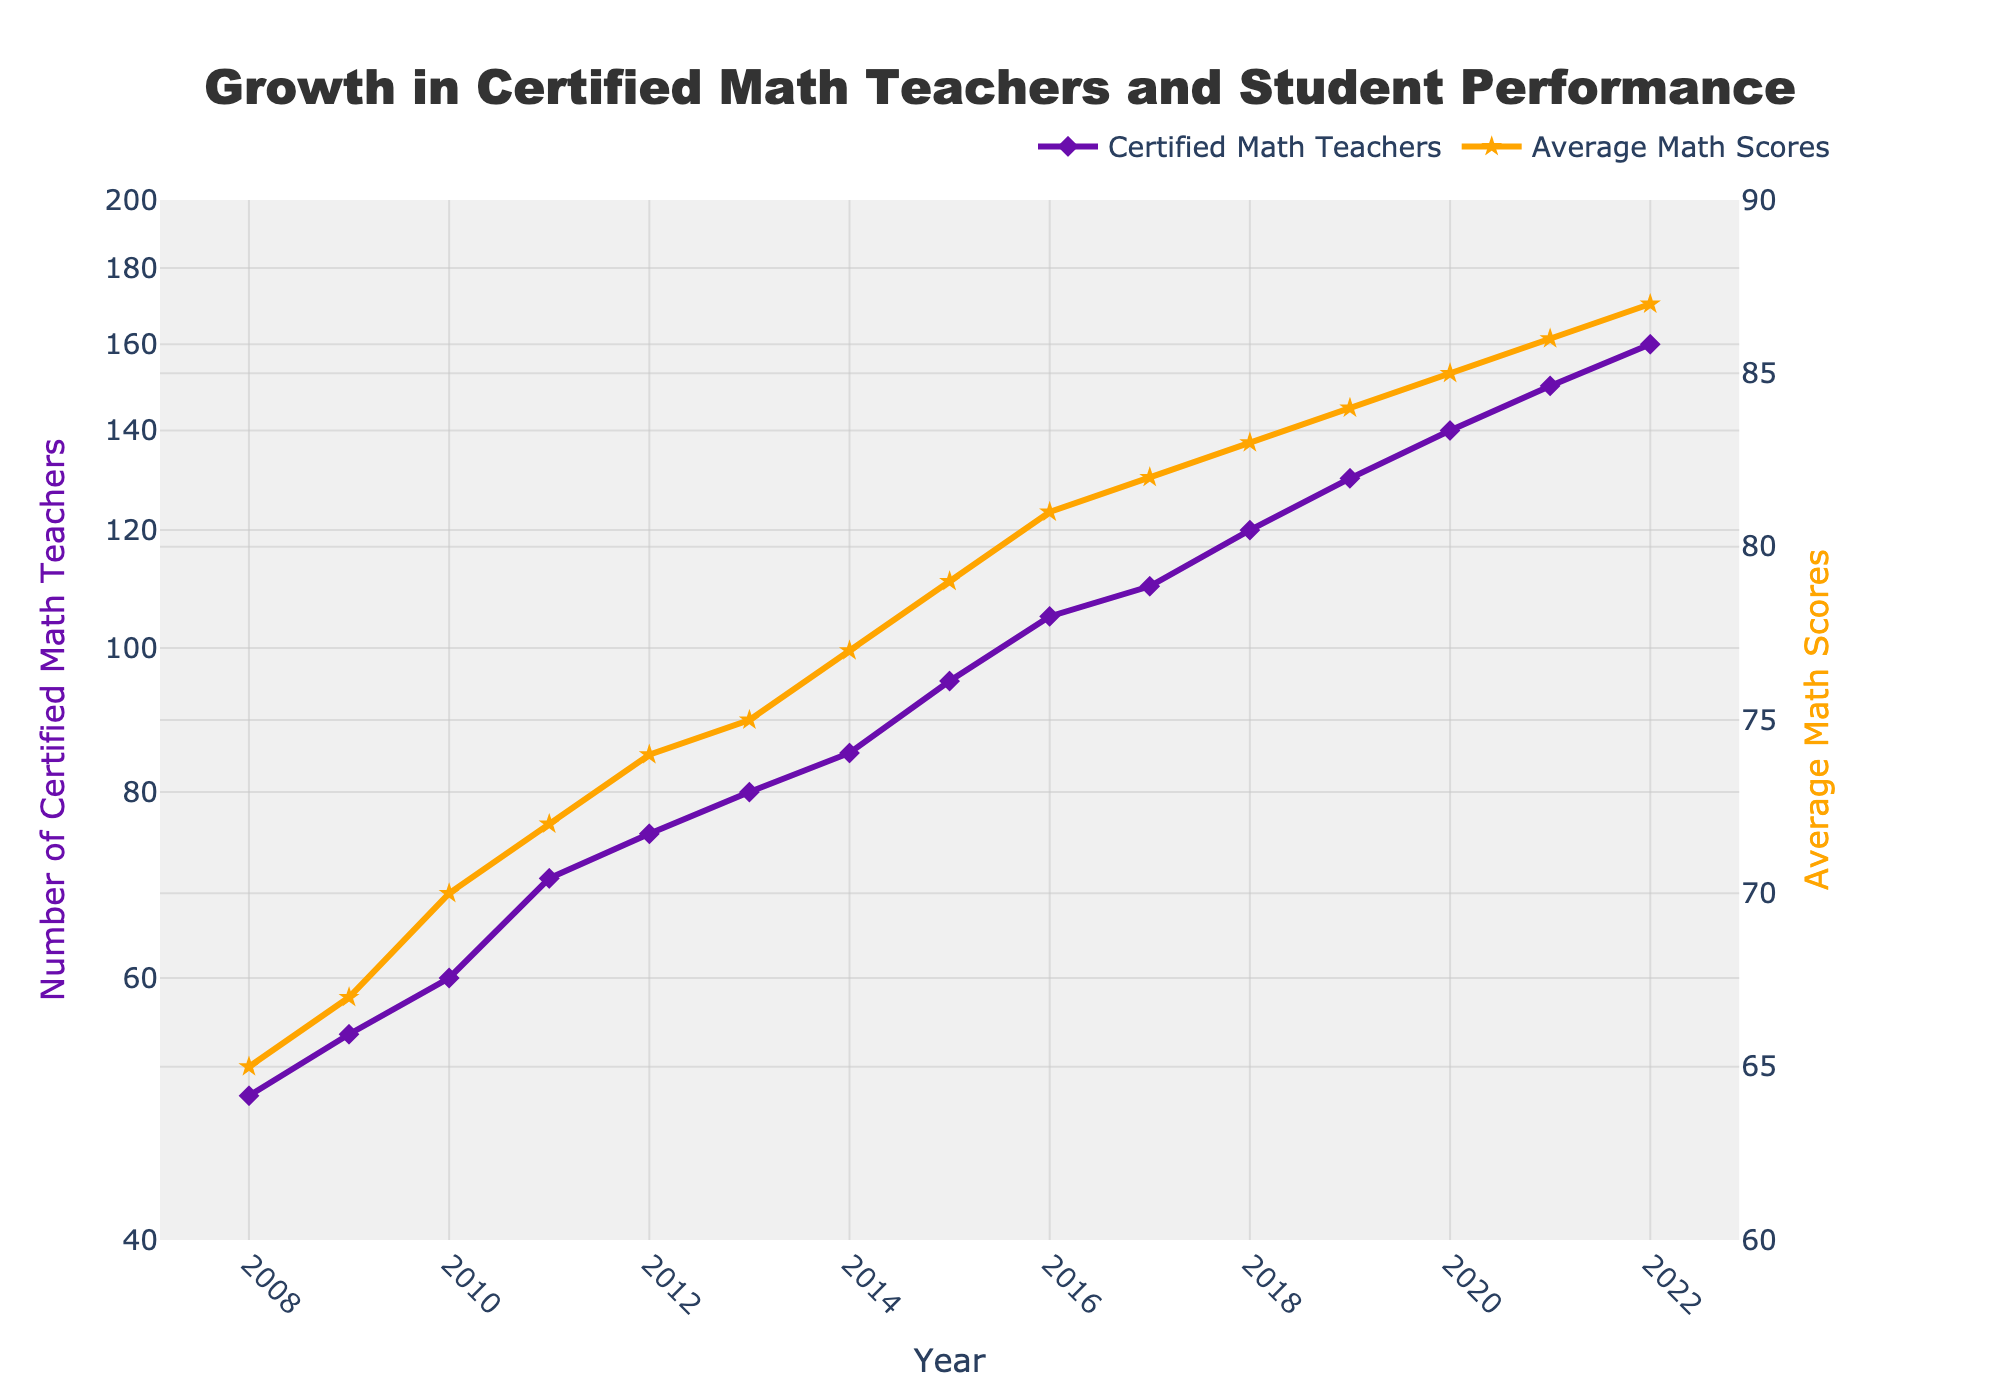How many certified math teachers were there in 2017? To answer this, look at the point on the plot for the year 2017 on the left Y-axis for "Number of Certified Math Teachers." The plot shows the value reaches 110.
Answer: 110 What's the average increase in math scores per year between 2012 and 2015? First, find the average math scores for 2012 (74) and 2015 (79). Then, calculate the difference between these scores (79 - 74 = 5). There are 3 years between 2012 and 2015, so divide the difference (5) by the number of years (3).
Answer: 1.67 In which year did the number of certified math teachers first exceed 100? Check the point at which the curve for the "Number of Certified Math Teachers" on the log scale crosses 100 on the y-axis. This happens in 2016 where it reaches 105.
Answer: 2016 Has the average math score ever decreased from one year to the next? Inspect the points on the secondary y-axis for "Average Math Scores." There is no visible decrease at any point throughout the years as the scores steadily increase.
Answer: No Which color represents the trend of average math scores? Examine the legend and match the color associated with "Average Math Scores." The plot uses an orange line to represent the math scores.
Answer: Orange What was the increase in the number of certified math teachers from 2013 to 2014? Look at the data points on the chart for the years 2013 (80 teachers) and 2014 (85 teachers). Calculate the difference between these two values (85 - 80).
Answer: 5 Is the scale used for the number of certified math teachers linear or logarithmic? The left y-axis for "Number of Certified Math Teachers" is stated to be log-scaled in the figure's description.
Answer: Logarithmic Between which two consecutive years was the largest increase in certified math teachers observed? Comparing the year-over-year differences, the largest increase was from 2014 (85) to 2015 (95), resulting in an increase of 10 teachers.
Answer: 2014 to 2015 How did the average math scores correlate with the number of certified math teachers? Both trends show an increasing pattern over time, implying a positive correlation; as the number of certified teachers increases, the average math scores also tend to increase.
Answer: Positive Between 2008 and 2022, which trend (math scores or certified teachers) has a steeper overall increase? Analyzing the slopes of the two lines, the "Number of Certified Math Teachers" demonstrates a more pronounced increase, particularly noticeable due to the use of a log scale.
Answer: Certified Teachers 